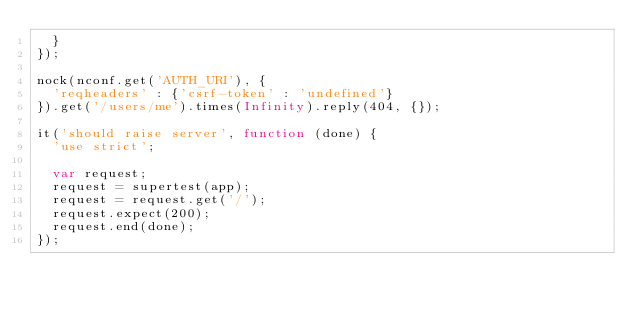Convert code to text. <code><loc_0><loc_0><loc_500><loc_500><_JavaScript_>  }
});

nock(nconf.get('AUTH_URI'), {
  'reqheaders' : {'csrf-token' : 'undefined'}
}).get('/users/me').times(Infinity).reply(404, {});

it('should raise server', function (done) {
  'use strict';

  var request;
  request = supertest(app);
  request = request.get('/');
  request.expect(200);
  request.end(done);
});</code> 